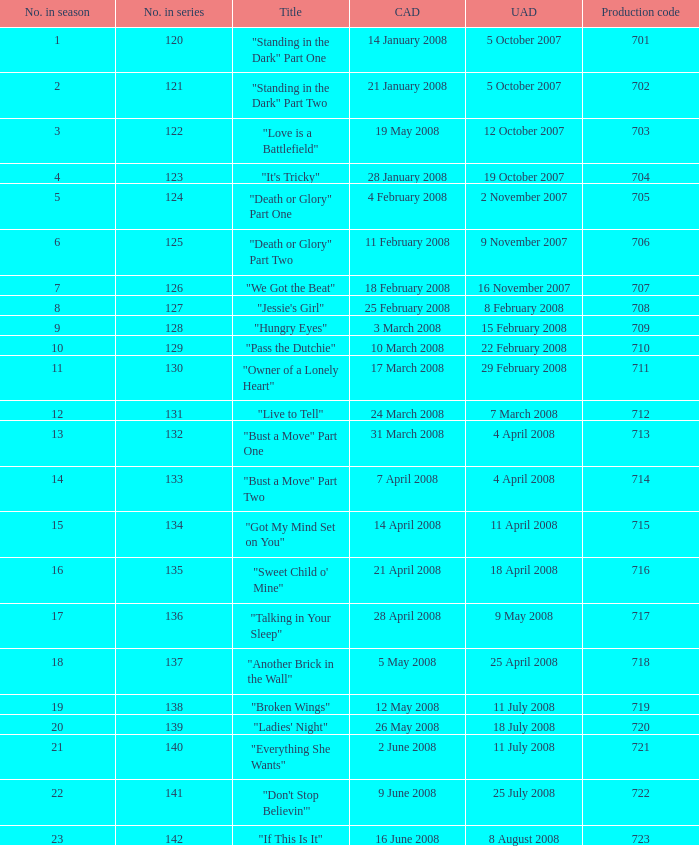Help me parse the entirety of this table. {'header': ['No. in season', 'No. in series', 'Title', 'CAD', 'UAD', 'Production code'], 'rows': [['1', '120', '"Standing in the Dark" Part One', '14 January 2008', '5 October 2007', '701'], ['2', '121', '"Standing in the Dark" Part Two', '21 January 2008', '5 October 2007', '702'], ['3', '122', '"Love is a Battlefield"', '19 May 2008', '12 October 2007', '703'], ['4', '123', '"It\'s Tricky"', '28 January 2008', '19 October 2007', '704'], ['5', '124', '"Death or Glory" Part One', '4 February 2008', '2 November 2007', '705'], ['6', '125', '"Death or Glory" Part Two', '11 February 2008', '9 November 2007', '706'], ['7', '126', '"We Got the Beat"', '18 February 2008', '16 November 2007', '707'], ['8', '127', '"Jessie\'s Girl"', '25 February 2008', '8 February 2008', '708'], ['9', '128', '"Hungry Eyes"', '3 March 2008', '15 February 2008', '709'], ['10', '129', '"Pass the Dutchie"', '10 March 2008', '22 February 2008', '710'], ['11', '130', '"Owner of a Lonely Heart"', '17 March 2008', '29 February 2008', '711'], ['12', '131', '"Live to Tell"', '24 March 2008', '7 March 2008', '712'], ['13', '132', '"Bust a Move" Part One', '31 March 2008', '4 April 2008', '713'], ['14', '133', '"Bust a Move" Part Two', '7 April 2008', '4 April 2008', '714'], ['15', '134', '"Got My Mind Set on You"', '14 April 2008', '11 April 2008', '715'], ['16', '135', '"Sweet Child o\' Mine"', '21 April 2008', '18 April 2008', '716'], ['17', '136', '"Talking in Your Sleep"', '28 April 2008', '9 May 2008', '717'], ['18', '137', '"Another Brick in the Wall"', '5 May 2008', '25 April 2008', '718'], ['19', '138', '"Broken Wings"', '12 May 2008', '11 July 2008', '719'], ['20', '139', '"Ladies\' Night"', '26 May 2008', '18 July 2008', '720'], ['21', '140', '"Everything She Wants"', '2 June 2008', '11 July 2008', '721'], ['22', '141', '"Don\'t Stop Believin\'"', '9 June 2008', '25 July 2008', '722'], ['23', '142', '"If This Is It"', '16 June 2008', '8 August 2008', '723']]} The episode titled "don't stop believin'" was what highest number of the season? 22.0. 